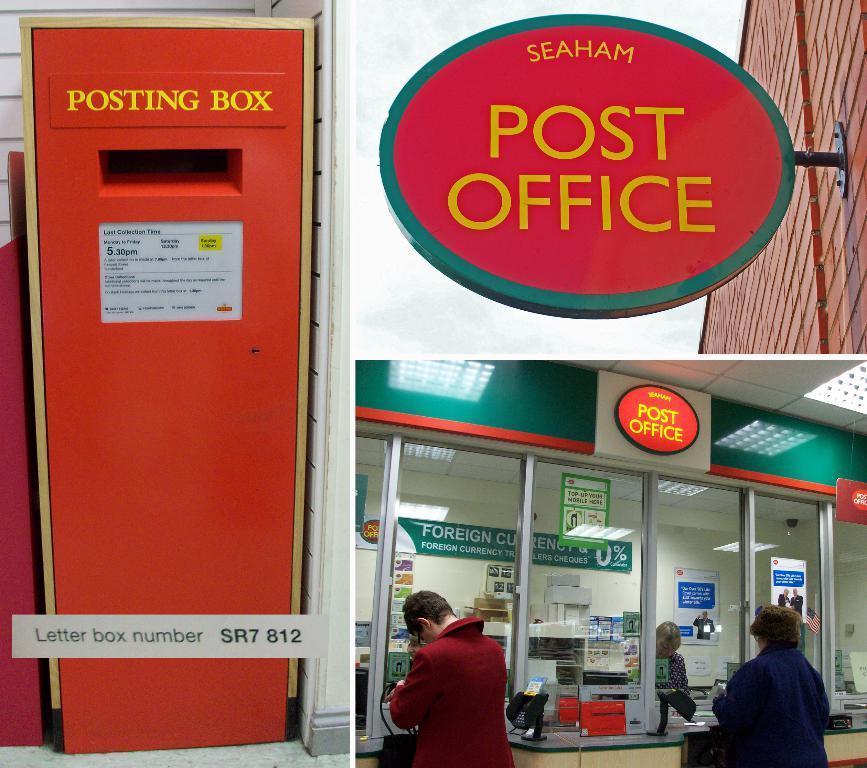In one or two sentences, can you explain what this image depicts? In the foreground I can see a group of people on the floor, a post box, boards, systems on the table. In the background I can see a wall and lights. On the top I can see the sky. This image is taken during a day. 